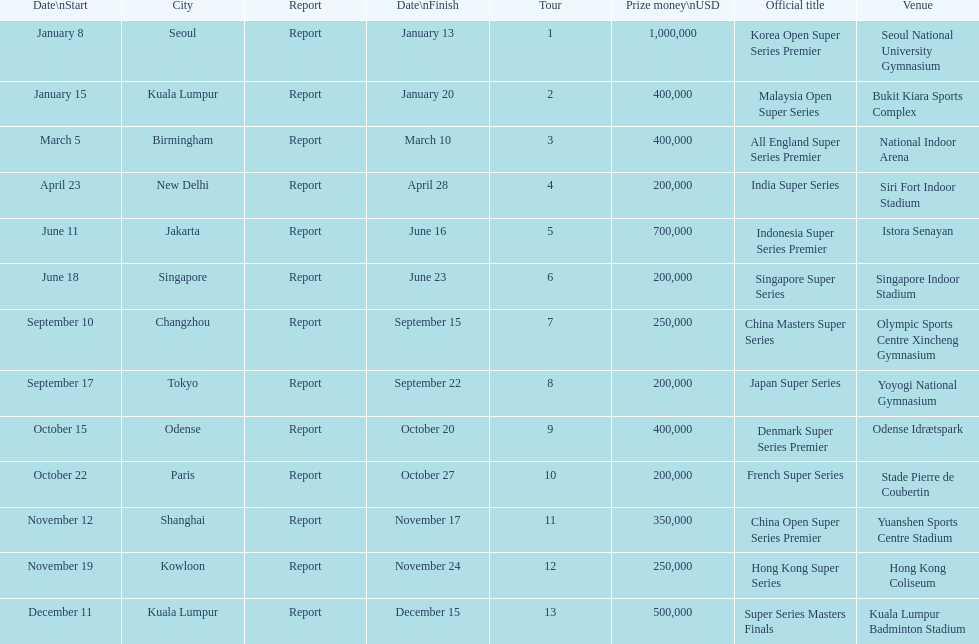How many happen in the final six months of the year? 7. 